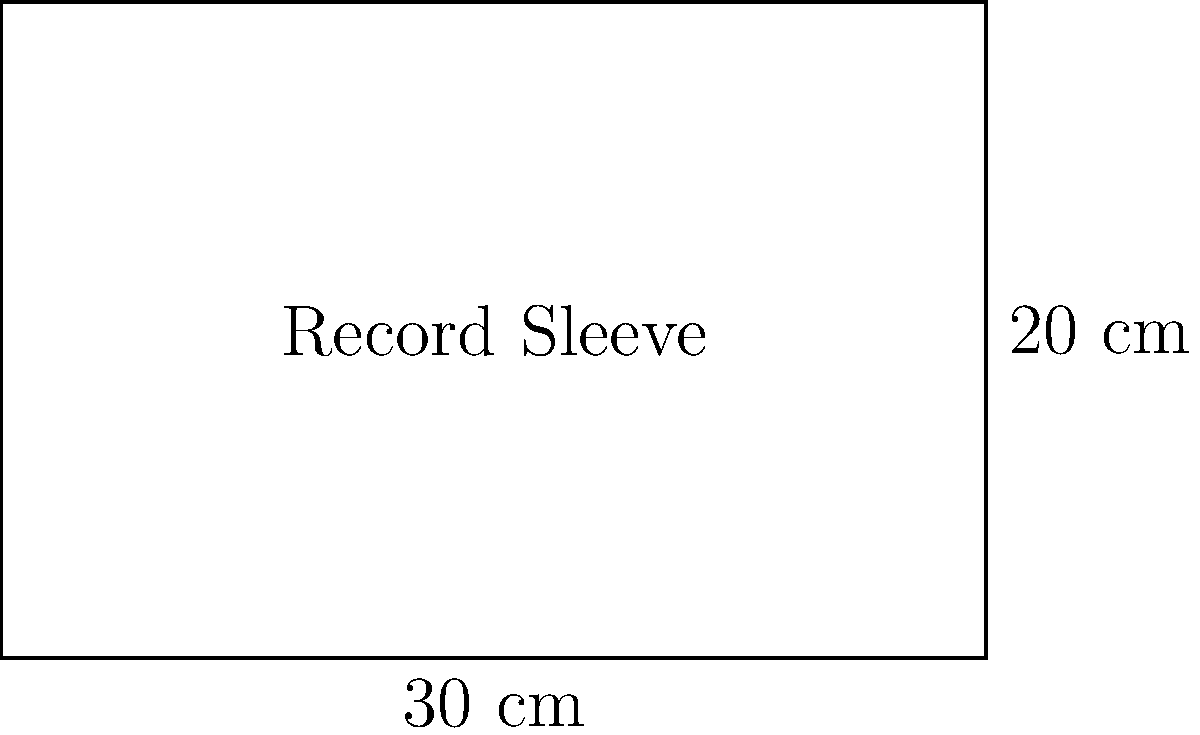You've just purchased a new vinyl record and want to add a protective plastic sleeve. The record sleeve measures 30 cm in width and 20 cm in height. What is the perimeter of the rectangular sleeve in centimeters? To find the perimeter of the rectangular record sleeve, we need to add up the lengths of all four sides. Let's break it down step-by-step:

1. Identify the dimensions:
   - Width (w) = 30 cm
   - Height (h) = 20 cm

2. The formula for the perimeter of a rectangle is:
   $$P = 2w + 2h$$
   where $P$ is the perimeter, $w$ is the width, and $h$ is the height.

3. Substitute the values into the formula:
   $$P = 2(30) + 2(20)$$

4. Simplify:
   $$P = 60 + 40$$

5. Calculate the final result:
   $$P = 100$$

Therefore, the perimeter of the rectangular record sleeve is 100 cm.
Answer: 100 cm 